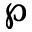<formula> <loc_0><loc_0><loc_500><loc_500>\wp</formula> 